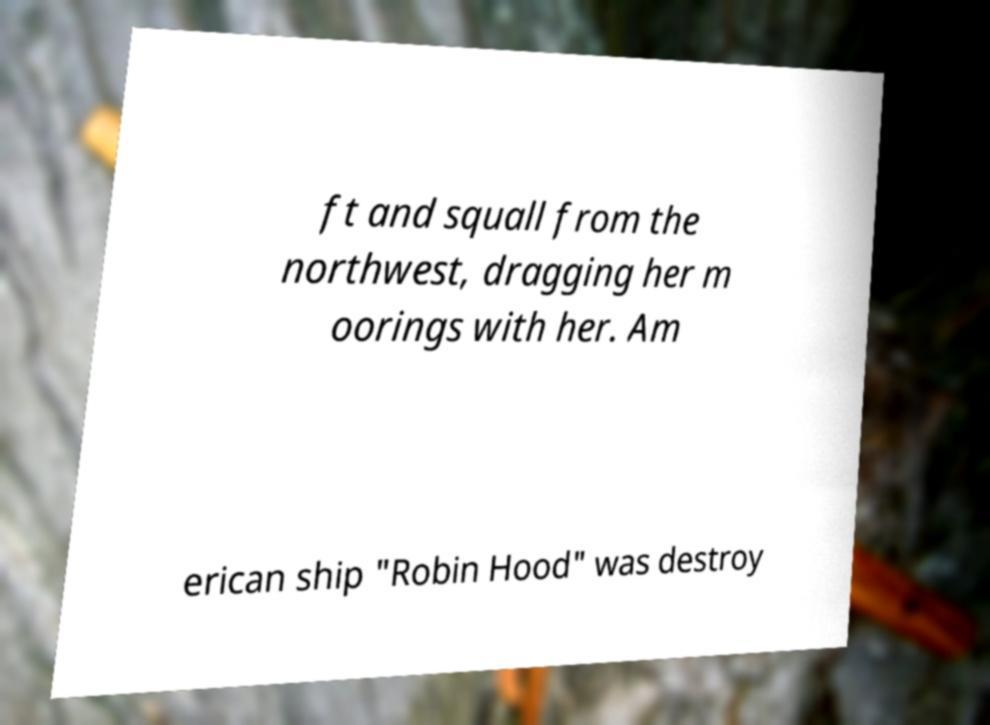I need the written content from this picture converted into text. Can you do that? ft and squall from the northwest, dragging her m oorings with her. Am erican ship "Robin Hood" was destroy 